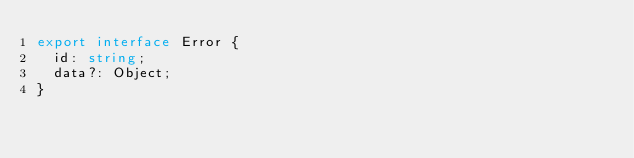<code> <loc_0><loc_0><loc_500><loc_500><_TypeScript_>export interface Error {
  id: string;
  data?: Object;
}
</code> 